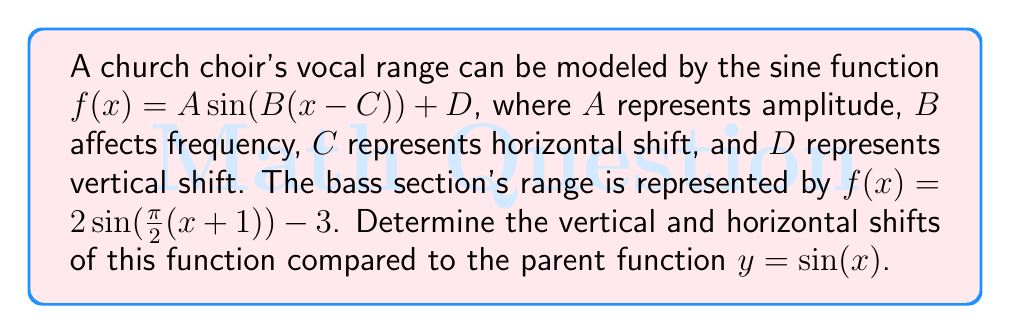Can you solve this math problem? To determine the vertical and horizontal shifts, we need to compare the given function to the parent sine function. Let's break this down step-by-step:

1. The parent sine function is $y = \sin(x)$.

2. Our given function is $f(x) = 2\sin(\frac{\pi}{2}(x+1)) - 3$.

3. To identify the shifts, we need to rewrite the function in the form $f(x) = A \sin(B(x-C)) + D$:

   $f(x) = 2\sin(\frac{\pi}{2}(x+1)) - 3$
   $= 2\sin(\frac{\pi}{2}x + \frac{\pi}{2}) - 3$
   $= 2\sin(\frac{\pi}{2}(x - (-1))) - 3$

4. Now we can identify each component:
   $A = 2$ (amplitude)
   $B = \frac{\pi}{2}$ (affects frequency)
   $C = -1$ (horizontal shift)
   $D = -3$ (vertical shift)

5. The horizontal shift is determined by $C$. When $C$ is negative, the graph shifts to the right. So, the graph shifts 1 unit to the right.

6. The vertical shift is determined by $D$. When $D$ is negative, the graph shifts down. So, the graph shifts 3 units down.
Answer: The function $f(x) = 2\sin(\frac{\pi}{2}(x+1)) - 3$ has a horizontal shift of 1 unit to the right and a vertical shift of 3 units down compared to the parent function $y = \sin(x)$. 